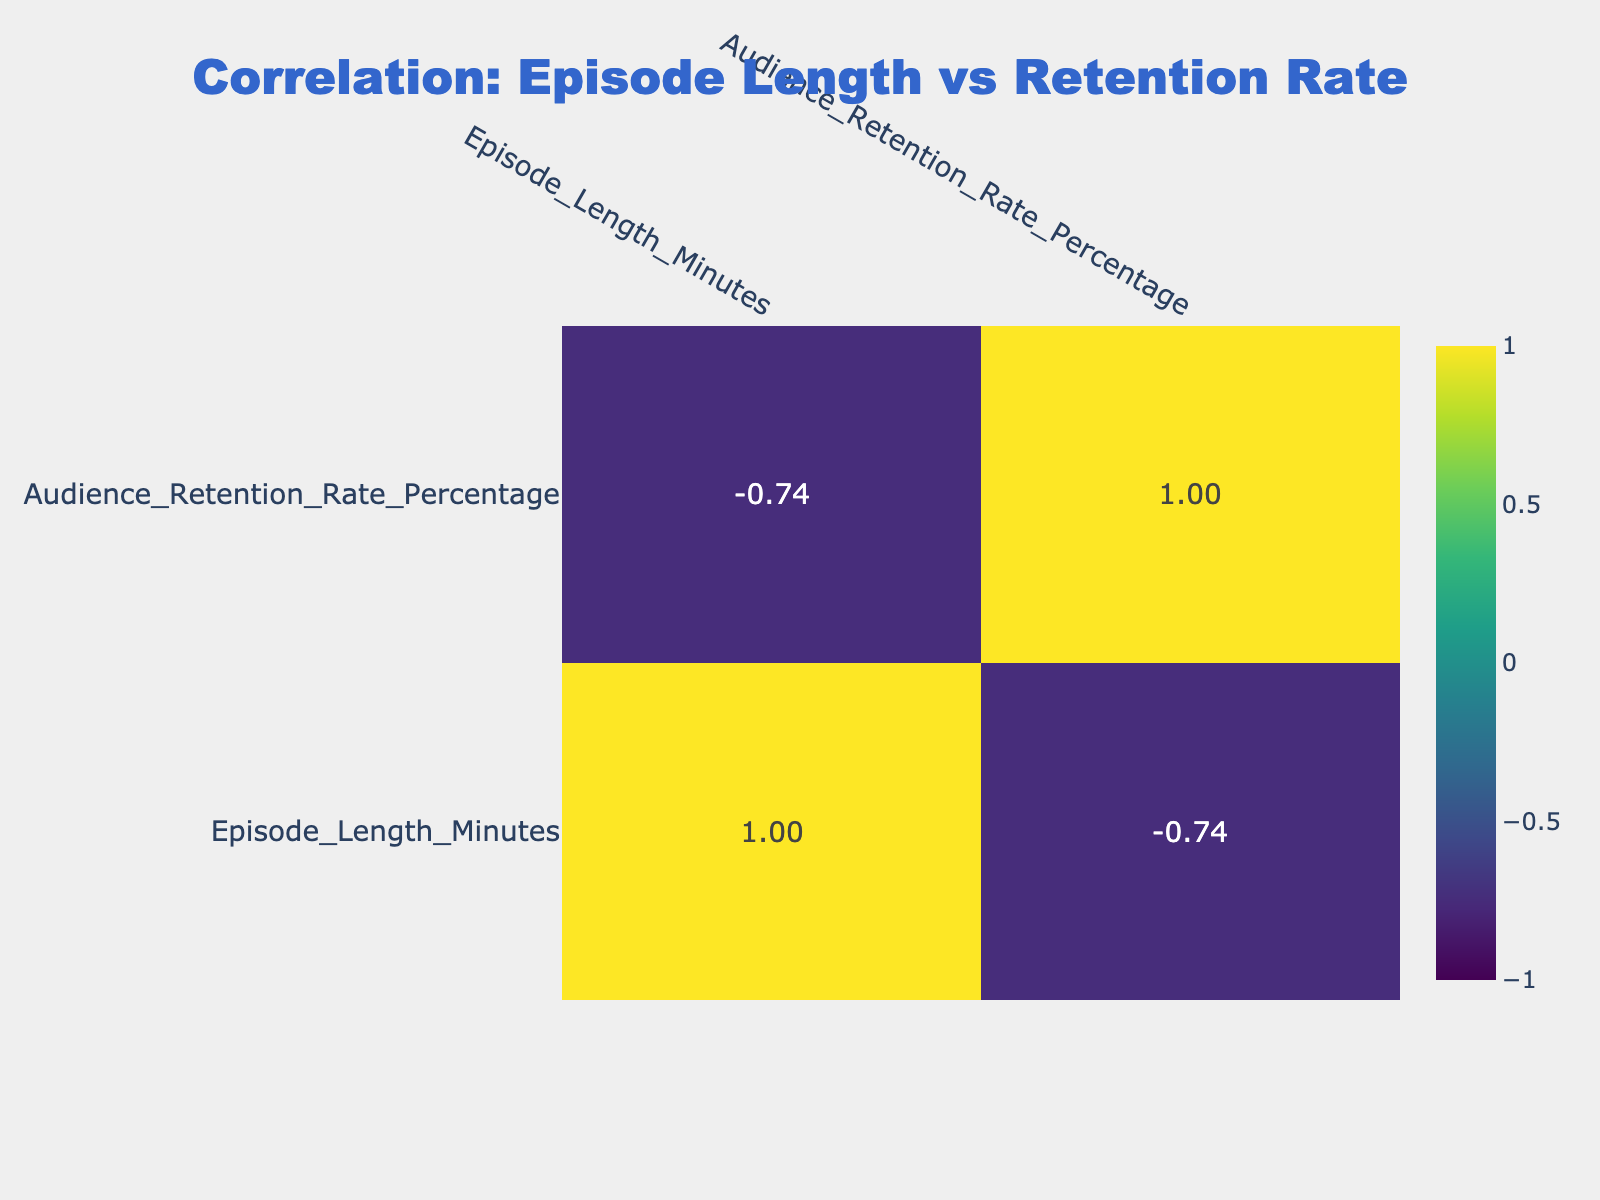What is the audience retention rate for "The Daily"? The table lists "The Daily" with an audience retention rate of 85%.
Answer: 85% What is the episode length for "How I Built This"? The table shows that "How I Built This" has an episode length of 60 minutes.
Answer: 60 Which podcast has the highest audience retention rate, and what is that rate? By scanning the audience retention rates, "The Daily" has the highest at 85%.
Answer: The Daily, 85 Is there a correlation between longer episode lengths and higher audience retention rates in the data provided? The correlation table would show values close to zero for the relationship, suggesting little to no correlation.
Answer: No What is the average audience retention rate of podcasts with an episode length greater than 60 minutes? The podcasts "The Joe Rogan Experience" (55%), "Armchair Expert" (65%) both have lengths greater than 60 minutes. The average is (55 + 65) / 2 = 60%.
Answer: 60% Which two podcasts have similar episode lengths and what are their audience retention rates? "Reply All" and "Lore" both have an episode length of 45 minutes, and their audience retention rates are 78% and 82% respectively.
Answer: Reply All (78%), Lore (82%) What is the difference in audience retention rate between "Stuff You Should Know" and "Freakonomics Radio"? "Stuff You Should Know" has a retention rate of 70%, while "Freakonomics Radio" has a rate of 75%, so the difference is 75 - 70 = 5%.
Answer: 5% What is the total episode length of all podcasts listed? The total can be calculated by summing all episode lengths (25 + 50 + 30 + 45 + 35 + 60 + 180 + 90 + 40 + 35 + 45 + 45 + 33 + 30 + 41) = 690 minutes.
Answer: 690 What percentages of podcasts have an audience retention rate above 75%? Looking at the data, "The Daily" (85%), "Science Vs" (80%), and "Lore" (82%) are above 75%. Out of 15 podcasts, that's 3, making the percentage (3/15) * 100 = 20%.
Answer: 20% 